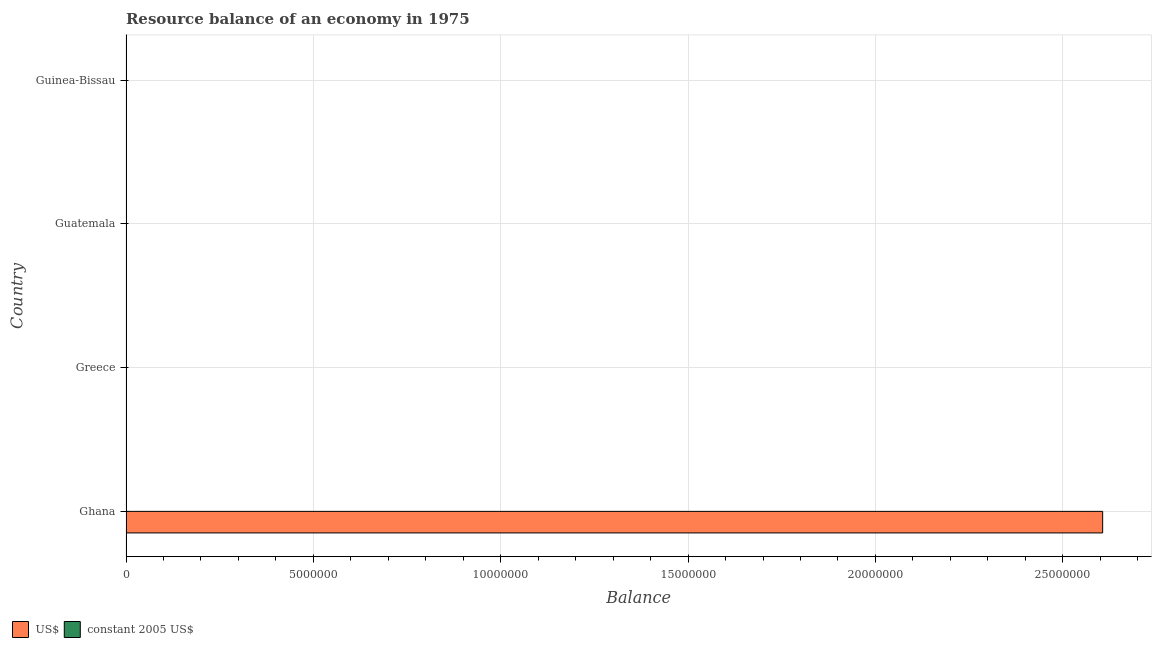Are the number of bars per tick equal to the number of legend labels?
Provide a short and direct response. No. Are the number of bars on each tick of the Y-axis equal?
Your answer should be compact. No. How many bars are there on the 4th tick from the top?
Keep it short and to the point. 2. What is the label of the 1st group of bars from the top?
Offer a very short reply. Guinea-Bissau. In how many cases, is the number of bars for a given country not equal to the number of legend labels?
Your answer should be very brief. 3. Across all countries, what is the maximum resource balance in constant us$?
Give a very brief answer. 4900. Across all countries, what is the minimum resource balance in us$?
Give a very brief answer. 0. In which country was the resource balance in constant us$ maximum?
Offer a terse response. Ghana. What is the total resource balance in constant us$ in the graph?
Provide a succinct answer. 4900. What is the difference between the resource balance in us$ in Guatemala and the resource balance in constant us$ in Guinea-Bissau?
Your answer should be very brief. 0. What is the average resource balance in constant us$ per country?
Ensure brevity in your answer.  1225. What is the difference between the resource balance in us$ and resource balance in constant us$ in Ghana?
Offer a very short reply. 2.61e+07. What is the difference between the highest and the lowest resource balance in constant us$?
Your answer should be very brief. 4900. In how many countries, is the resource balance in us$ greater than the average resource balance in us$ taken over all countries?
Your answer should be very brief. 1. How many countries are there in the graph?
Your answer should be very brief. 4. Does the graph contain any zero values?
Give a very brief answer. Yes. Does the graph contain grids?
Offer a terse response. Yes. Where does the legend appear in the graph?
Give a very brief answer. Bottom left. How are the legend labels stacked?
Offer a terse response. Horizontal. What is the title of the graph?
Offer a terse response. Resource balance of an economy in 1975. Does "Public credit registry" appear as one of the legend labels in the graph?
Ensure brevity in your answer.  No. What is the label or title of the X-axis?
Provide a short and direct response. Balance. What is the label or title of the Y-axis?
Provide a short and direct response. Country. What is the Balance of US$ in Ghana?
Provide a short and direct response. 2.61e+07. What is the Balance in constant 2005 US$ in Ghana?
Give a very brief answer. 4900. What is the Balance in US$ in Greece?
Your response must be concise. 0. What is the Balance in US$ in Guinea-Bissau?
Ensure brevity in your answer.  0. Across all countries, what is the maximum Balance in US$?
Your response must be concise. 2.61e+07. Across all countries, what is the maximum Balance in constant 2005 US$?
Your answer should be very brief. 4900. Across all countries, what is the minimum Balance in US$?
Provide a succinct answer. 0. What is the total Balance in US$ in the graph?
Your response must be concise. 2.61e+07. What is the total Balance of constant 2005 US$ in the graph?
Offer a terse response. 4900. What is the average Balance in US$ per country?
Your response must be concise. 6.52e+06. What is the average Balance in constant 2005 US$ per country?
Ensure brevity in your answer.  1225. What is the difference between the Balance in US$ and Balance in constant 2005 US$ in Ghana?
Offer a terse response. 2.61e+07. What is the difference between the highest and the lowest Balance in US$?
Give a very brief answer. 2.61e+07. What is the difference between the highest and the lowest Balance in constant 2005 US$?
Keep it short and to the point. 4900. 